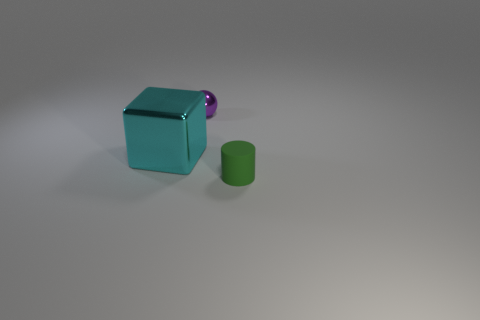Are there any other things that are the same size as the cyan thing?
Ensure brevity in your answer.  No. Are there any purple things made of the same material as the tiny cylinder?
Provide a short and direct response. No. Does the small purple thing that is right of the big cyan metallic thing have the same material as the object that is on the left side of the tiny purple metal sphere?
Make the answer very short. Yes. How many large cyan matte objects are there?
Provide a short and direct response. 0. What shape is the thing that is in front of the large cyan shiny cube?
Provide a short and direct response. Cylinder. How many other things are the same size as the green rubber cylinder?
Provide a short and direct response. 1. Does the thing in front of the shiny block have the same shape as the small object that is left of the green matte object?
Give a very brief answer. No. How many tiny green matte things are to the right of the cyan cube?
Provide a short and direct response. 1. What is the color of the tiny thing that is in front of the big cyan metal cube?
Provide a short and direct response. Green. Are there more large blue metallic blocks than tiny metallic spheres?
Make the answer very short. No. 